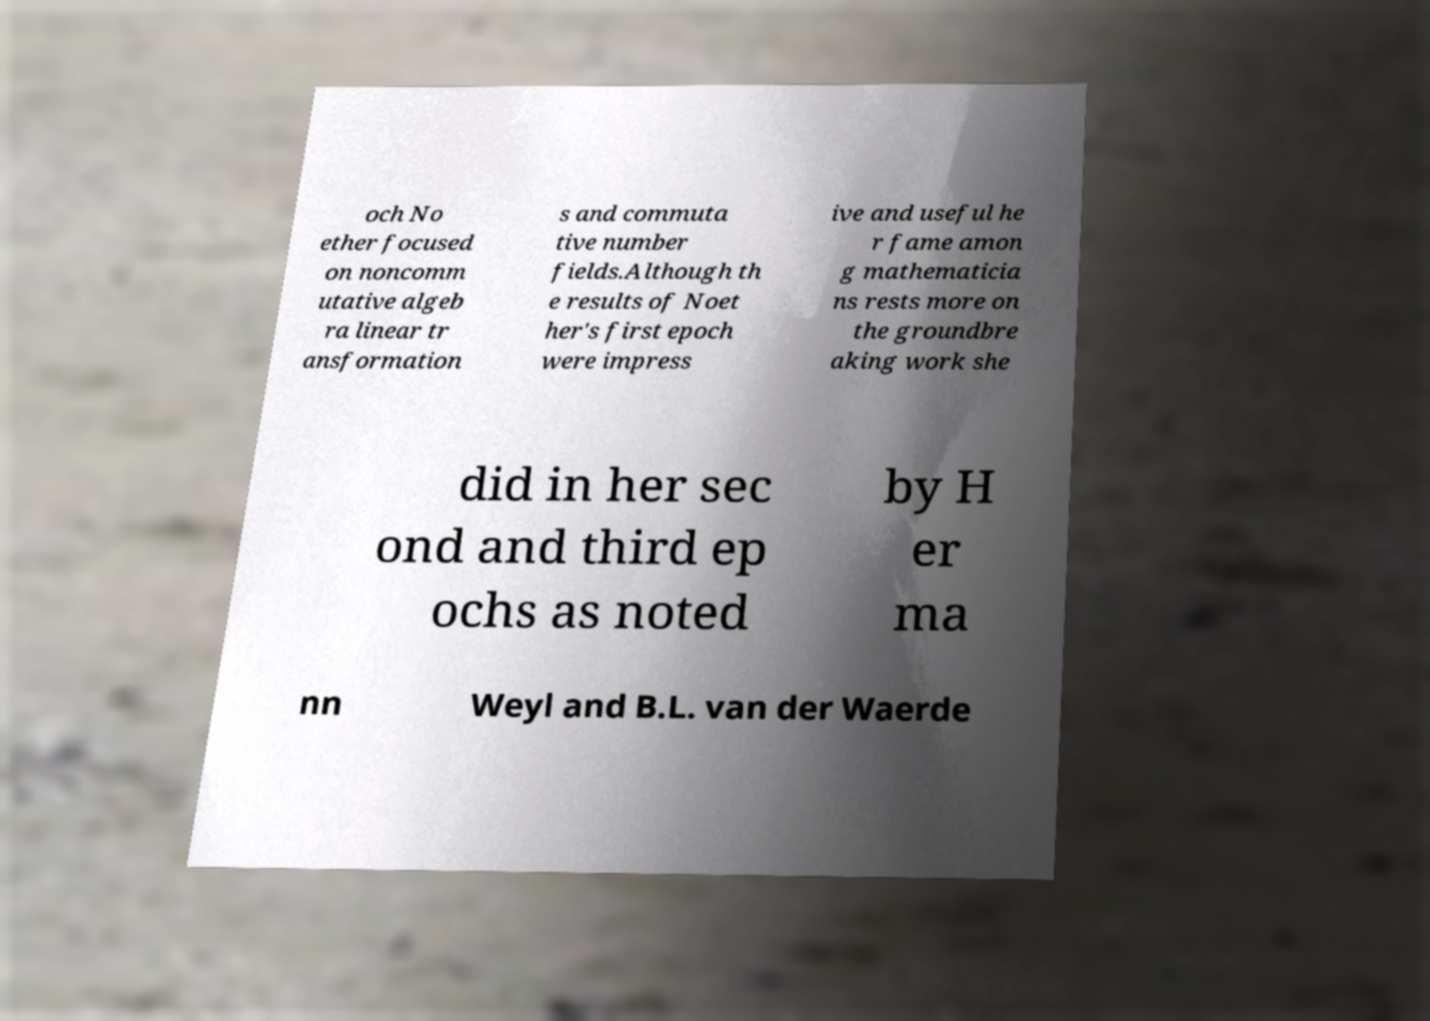For documentation purposes, I need the text within this image transcribed. Could you provide that? och No ether focused on noncomm utative algeb ra linear tr ansformation s and commuta tive number fields.Although th e results of Noet her's first epoch were impress ive and useful he r fame amon g mathematicia ns rests more on the groundbre aking work she did in her sec ond and third ep ochs as noted by H er ma nn Weyl and B.L. van der Waerde 